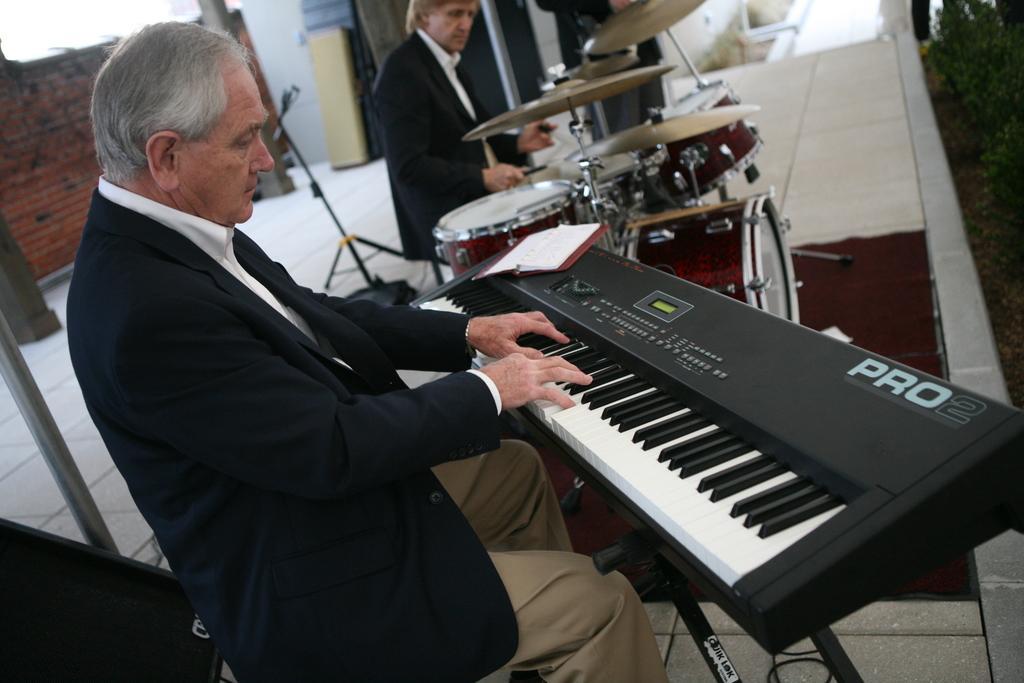Describe this image in one or two sentences. In this picture we can see a man who is playing piano. He is in black color suit. Here we can see a man who is playing drums. This is floor and there is a wall. 